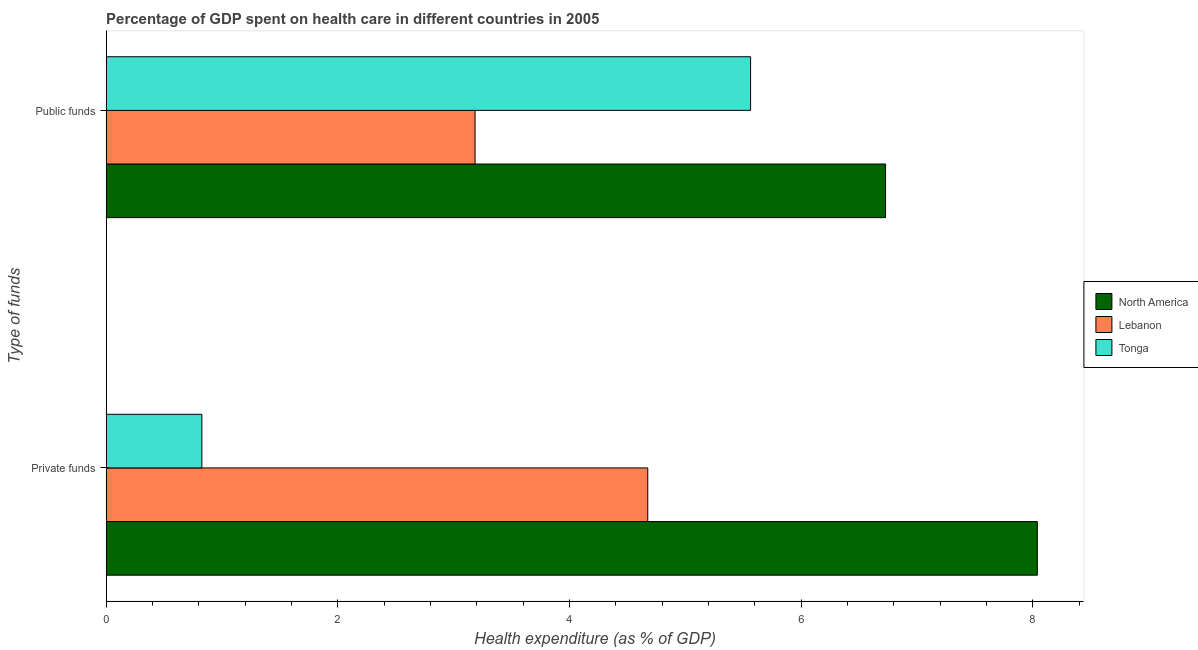How many different coloured bars are there?
Your response must be concise. 3. How many bars are there on the 2nd tick from the bottom?
Offer a very short reply. 3. What is the label of the 1st group of bars from the top?
Provide a succinct answer. Public funds. What is the amount of private funds spent in healthcare in North America?
Offer a terse response. 8.04. Across all countries, what is the maximum amount of public funds spent in healthcare?
Your answer should be compact. 6.73. Across all countries, what is the minimum amount of public funds spent in healthcare?
Offer a terse response. 3.18. In which country was the amount of public funds spent in healthcare maximum?
Give a very brief answer. North America. In which country was the amount of public funds spent in healthcare minimum?
Make the answer very short. Lebanon. What is the total amount of private funds spent in healthcare in the graph?
Offer a terse response. 13.54. What is the difference between the amount of public funds spent in healthcare in North America and that in Tonga?
Give a very brief answer. 1.17. What is the difference between the amount of private funds spent in healthcare in Tonga and the amount of public funds spent in healthcare in Lebanon?
Make the answer very short. -2.36. What is the average amount of public funds spent in healthcare per country?
Provide a succinct answer. 5.16. What is the difference between the amount of public funds spent in healthcare and amount of private funds spent in healthcare in Tonga?
Keep it short and to the point. 4.74. In how many countries, is the amount of public funds spent in healthcare greater than 8 %?
Your answer should be very brief. 0. What is the ratio of the amount of public funds spent in healthcare in Tonga to that in North America?
Provide a short and direct response. 0.83. In how many countries, is the amount of private funds spent in healthcare greater than the average amount of private funds spent in healthcare taken over all countries?
Your response must be concise. 2. What does the 3rd bar from the top in Private funds represents?
Your response must be concise. North America. What does the 2nd bar from the bottom in Public funds represents?
Give a very brief answer. Lebanon. What is the difference between two consecutive major ticks on the X-axis?
Ensure brevity in your answer.  2. Are the values on the major ticks of X-axis written in scientific E-notation?
Your response must be concise. No. Does the graph contain any zero values?
Offer a very short reply. No. Does the graph contain grids?
Your response must be concise. No. Where does the legend appear in the graph?
Your answer should be very brief. Center right. How many legend labels are there?
Provide a short and direct response. 3. What is the title of the graph?
Make the answer very short. Percentage of GDP spent on health care in different countries in 2005. Does "Pakistan" appear as one of the legend labels in the graph?
Ensure brevity in your answer.  No. What is the label or title of the X-axis?
Your answer should be very brief. Health expenditure (as % of GDP). What is the label or title of the Y-axis?
Keep it short and to the point. Type of funds. What is the Health expenditure (as % of GDP) in North America in Private funds?
Offer a terse response. 8.04. What is the Health expenditure (as % of GDP) in Lebanon in Private funds?
Give a very brief answer. 4.68. What is the Health expenditure (as % of GDP) in Tonga in Private funds?
Ensure brevity in your answer.  0.83. What is the Health expenditure (as % of GDP) of North America in Public funds?
Make the answer very short. 6.73. What is the Health expenditure (as % of GDP) of Lebanon in Public funds?
Provide a succinct answer. 3.18. What is the Health expenditure (as % of GDP) in Tonga in Public funds?
Make the answer very short. 5.56. Across all Type of funds, what is the maximum Health expenditure (as % of GDP) in North America?
Ensure brevity in your answer.  8.04. Across all Type of funds, what is the maximum Health expenditure (as % of GDP) in Lebanon?
Your response must be concise. 4.68. Across all Type of funds, what is the maximum Health expenditure (as % of GDP) of Tonga?
Your answer should be very brief. 5.56. Across all Type of funds, what is the minimum Health expenditure (as % of GDP) in North America?
Provide a succinct answer. 6.73. Across all Type of funds, what is the minimum Health expenditure (as % of GDP) in Lebanon?
Give a very brief answer. 3.18. Across all Type of funds, what is the minimum Health expenditure (as % of GDP) in Tonga?
Offer a very short reply. 0.83. What is the total Health expenditure (as % of GDP) of North America in the graph?
Make the answer very short. 14.77. What is the total Health expenditure (as % of GDP) in Lebanon in the graph?
Ensure brevity in your answer.  7.86. What is the total Health expenditure (as % of GDP) of Tonga in the graph?
Ensure brevity in your answer.  6.39. What is the difference between the Health expenditure (as % of GDP) of North America in Private funds and that in Public funds?
Keep it short and to the point. 1.31. What is the difference between the Health expenditure (as % of GDP) of Lebanon in Private funds and that in Public funds?
Offer a very short reply. 1.49. What is the difference between the Health expenditure (as % of GDP) of Tonga in Private funds and that in Public funds?
Your answer should be very brief. -4.74. What is the difference between the Health expenditure (as % of GDP) in North America in Private funds and the Health expenditure (as % of GDP) in Lebanon in Public funds?
Make the answer very short. 4.85. What is the difference between the Health expenditure (as % of GDP) of North America in Private funds and the Health expenditure (as % of GDP) of Tonga in Public funds?
Ensure brevity in your answer.  2.48. What is the difference between the Health expenditure (as % of GDP) in Lebanon in Private funds and the Health expenditure (as % of GDP) in Tonga in Public funds?
Provide a short and direct response. -0.89. What is the average Health expenditure (as % of GDP) of North America per Type of funds?
Offer a terse response. 7.38. What is the average Health expenditure (as % of GDP) in Lebanon per Type of funds?
Give a very brief answer. 3.93. What is the average Health expenditure (as % of GDP) of Tonga per Type of funds?
Provide a succinct answer. 3.19. What is the difference between the Health expenditure (as % of GDP) of North America and Health expenditure (as % of GDP) of Lebanon in Private funds?
Your response must be concise. 3.36. What is the difference between the Health expenditure (as % of GDP) in North America and Health expenditure (as % of GDP) in Tonga in Private funds?
Your response must be concise. 7.21. What is the difference between the Health expenditure (as % of GDP) of Lebanon and Health expenditure (as % of GDP) of Tonga in Private funds?
Your answer should be very brief. 3.85. What is the difference between the Health expenditure (as % of GDP) of North America and Health expenditure (as % of GDP) of Lebanon in Public funds?
Make the answer very short. 3.54. What is the difference between the Health expenditure (as % of GDP) of North America and Health expenditure (as % of GDP) of Tonga in Public funds?
Give a very brief answer. 1.17. What is the difference between the Health expenditure (as % of GDP) of Lebanon and Health expenditure (as % of GDP) of Tonga in Public funds?
Provide a short and direct response. -2.38. What is the ratio of the Health expenditure (as % of GDP) in North America in Private funds to that in Public funds?
Keep it short and to the point. 1.19. What is the ratio of the Health expenditure (as % of GDP) of Lebanon in Private funds to that in Public funds?
Give a very brief answer. 1.47. What is the ratio of the Health expenditure (as % of GDP) in Tonga in Private funds to that in Public funds?
Provide a succinct answer. 0.15. What is the difference between the highest and the second highest Health expenditure (as % of GDP) in North America?
Offer a very short reply. 1.31. What is the difference between the highest and the second highest Health expenditure (as % of GDP) of Lebanon?
Provide a short and direct response. 1.49. What is the difference between the highest and the second highest Health expenditure (as % of GDP) in Tonga?
Keep it short and to the point. 4.74. What is the difference between the highest and the lowest Health expenditure (as % of GDP) in North America?
Offer a terse response. 1.31. What is the difference between the highest and the lowest Health expenditure (as % of GDP) in Lebanon?
Give a very brief answer. 1.49. What is the difference between the highest and the lowest Health expenditure (as % of GDP) in Tonga?
Your answer should be compact. 4.74. 